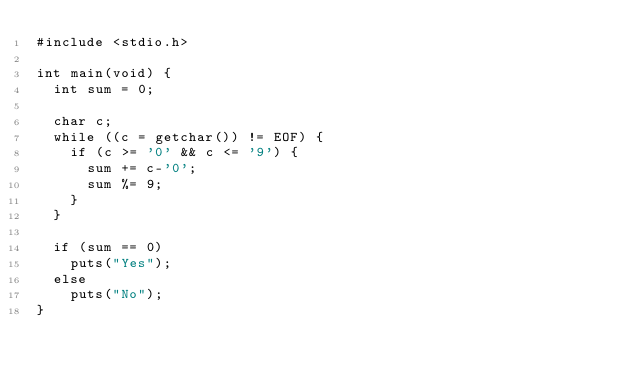Convert code to text. <code><loc_0><loc_0><loc_500><loc_500><_C_>#include <stdio.h>

int main(void) {
	int sum = 0;

	char c;
	while ((c = getchar()) != EOF) {
		if (c >= '0' && c <= '9') {
			sum += c-'0';
			sum %= 9;
		}
	}

	if (sum == 0)
		puts("Yes");
	else
		puts("No");
}
</code> 